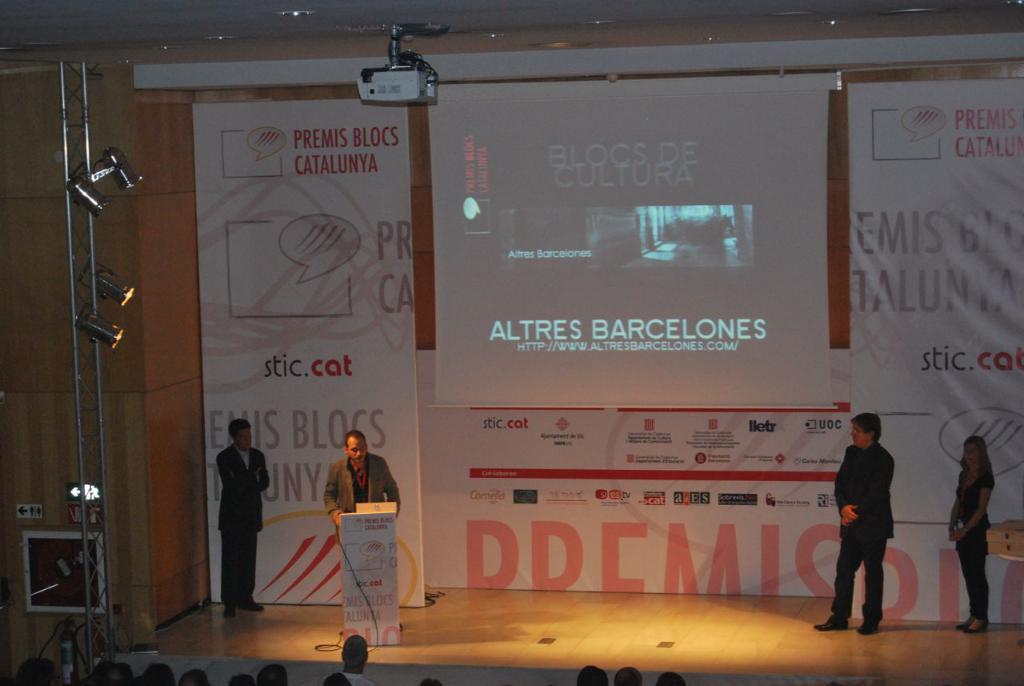Please provide a concise description of this image. In this picture we can see a person standing and talking in front of mike, few people are standing on the stage, we can see the banner on which we can see a projected screen on the board, in front we can see few people are watching. 